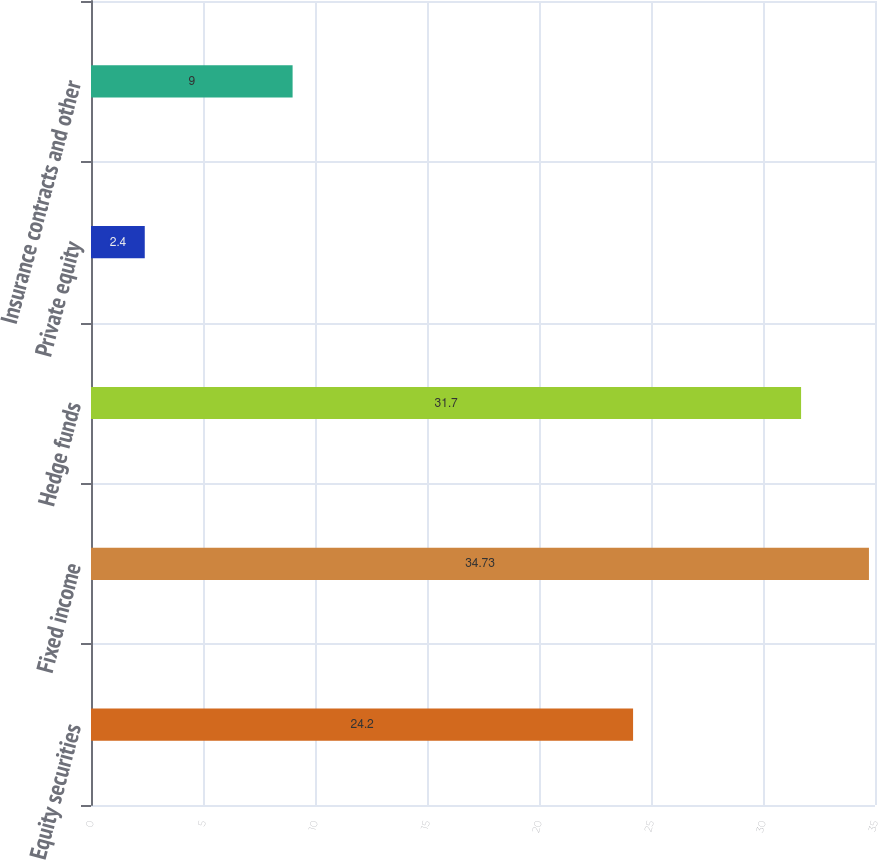Convert chart to OTSL. <chart><loc_0><loc_0><loc_500><loc_500><bar_chart><fcel>Equity securities<fcel>Fixed income<fcel>Hedge funds<fcel>Private equity<fcel>Insurance contracts and other<nl><fcel>24.2<fcel>34.73<fcel>31.7<fcel>2.4<fcel>9<nl></chart> 